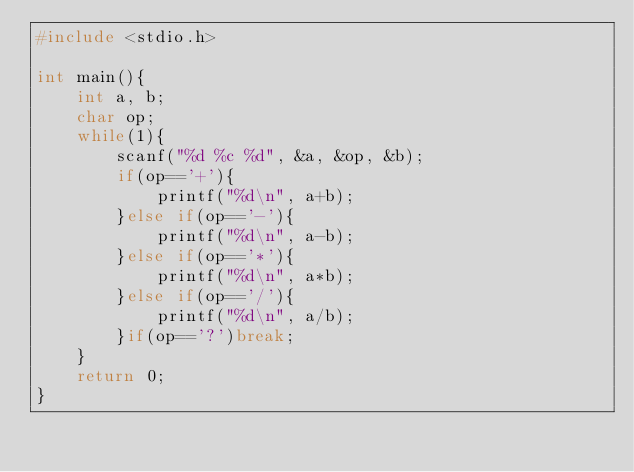Convert code to text. <code><loc_0><loc_0><loc_500><loc_500><_C_>#include <stdio.h>

int main(){
    int a, b;
    char op;
    while(1){
        scanf("%d %c %d", &a, &op, &b);
        if(op=='+'){
            printf("%d\n", a+b);
        }else if(op=='-'){
            printf("%d\n", a-b);
        }else if(op=='*'){
            printf("%d\n", a*b);
        }else if(op=='/'){
            printf("%d\n", a/b);
        }if(op=='?')break;
    }
    return 0;
} </code> 